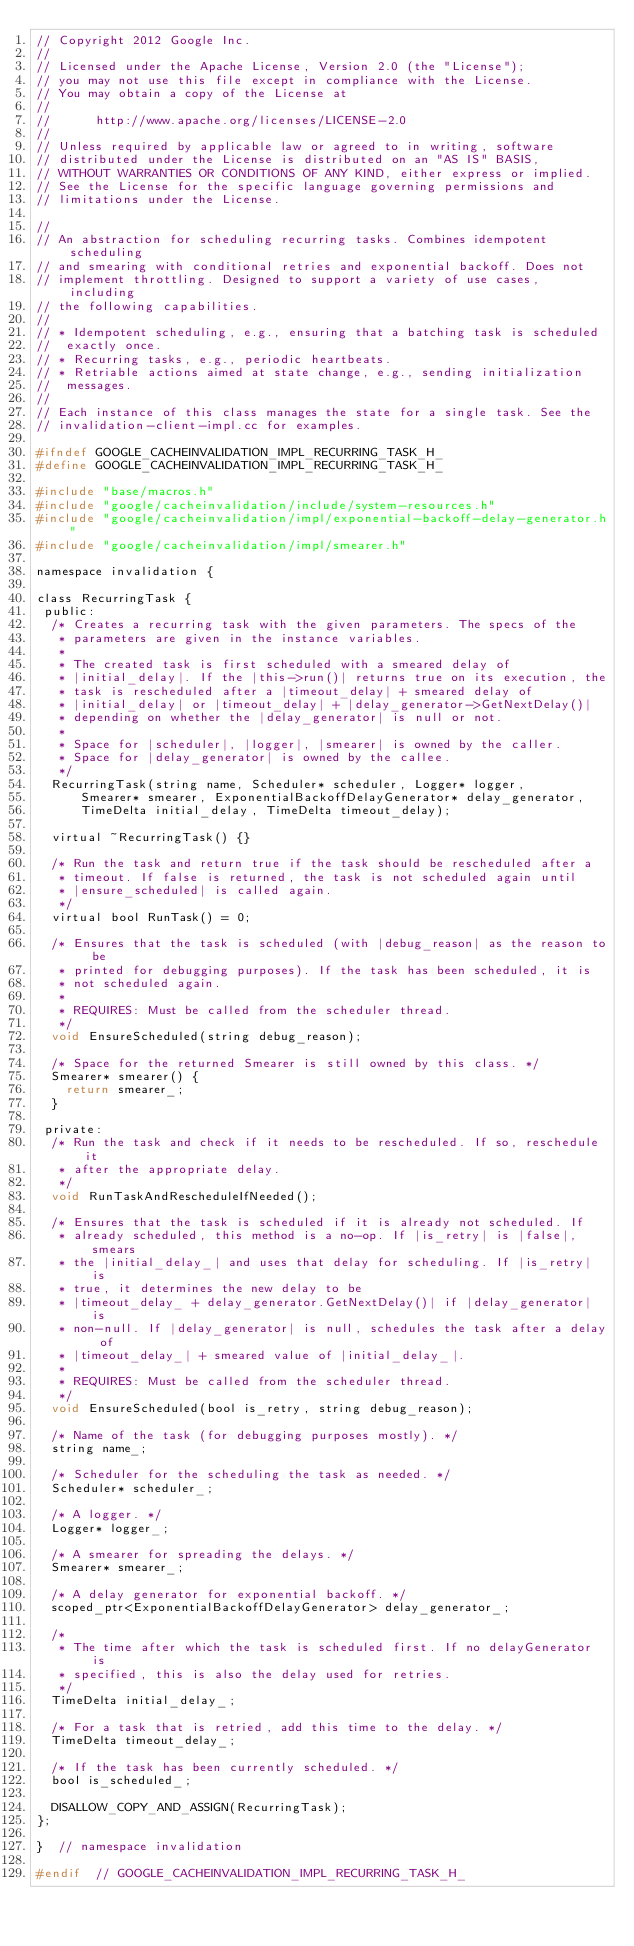<code> <loc_0><loc_0><loc_500><loc_500><_C_>// Copyright 2012 Google Inc.
//
// Licensed under the Apache License, Version 2.0 (the "License");
// you may not use this file except in compliance with the License.
// You may obtain a copy of the License at
//
//      http://www.apache.org/licenses/LICENSE-2.0
//
// Unless required by applicable law or agreed to in writing, software
// distributed under the License is distributed on an "AS IS" BASIS,
// WITHOUT WARRANTIES OR CONDITIONS OF ANY KIND, either express or implied.
// See the License for the specific language governing permissions and
// limitations under the License.

//
// An abstraction for scheduling recurring tasks. Combines idempotent scheduling
// and smearing with conditional retries and exponential backoff. Does not
// implement throttling. Designed to support a variety of use cases, including
// the following capabilities.
//
// * Idempotent scheduling, e.g., ensuring that a batching task is scheduled
//  exactly once.
// * Recurring tasks, e.g., periodic heartbeats.
// * Retriable actions aimed at state change, e.g., sending initialization
//  messages.
//
// Each instance of this class manages the state for a single task. See the
// invalidation-client-impl.cc for examples.

#ifndef GOOGLE_CACHEINVALIDATION_IMPL_RECURRING_TASK_H_
#define GOOGLE_CACHEINVALIDATION_IMPL_RECURRING_TASK_H_

#include "base/macros.h"
#include "google/cacheinvalidation/include/system-resources.h"
#include "google/cacheinvalidation/impl/exponential-backoff-delay-generator.h"
#include "google/cacheinvalidation/impl/smearer.h"

namespace invalidation {

class RecurringTask {
 public:
  /* Creates a recurring task with the given parameters. The specs of the
   * parameters are given in the instance variables.
   *
   * The created task is first scheduled with a smeared delay of
   * |initial_delay|. If the |this->run()| returns true on its execution, the
   * task is rescheduled after a |timeout_delay| + smeared delay of
   * |initial_delay| or |timeout_delay| + |delay_generator->GetNextDelay()|
   * depending on whether the |delay_generator| is null or not.
   *
   * Space for |scheduler|, |logger|, |smearer| is owned by the caller.
   * Space for |delay_generator| is owned by the callee.
   */
  RecurringTask(string name, Scheduler* scheduler, Logger* logger,
      Smearer* smearer, ExponentialBackoffDelayGenerator* delay_generator,
      TimeDelta initial_delay, TimeDelta timeout_delay);

  virtual ~RecurringTask() {}

  /* Run the task and return true if the task should be rescheduled after a
   * timeout. If false is returned, the task is not scheduled again until
   * |ensure_scheduled| is called again.
   */
  virtual bool RunTask() = 0;

  /* Ensures that the task is scheduled (with |debug_reason| as the reason to be
   * printed for debugging purposes). If the task has been scheduled, it is
   * not scheduled again.
   *
   * REQUIRES: Must be called from the scheduler thread.
   */
  void EnsureScheduled(string debug_reason);

  /* Space for the returned Smearer is still owned by this class. */
  Smearer* smearer() {
    return smearer_;
  }

 private:
  /* Run the task and check if it needs to be rescheduled. If so, reschedule it
   * after the appropriate delay.
   */
  void RunTaskAndRescheduleIfNeeded();

  /* Ensures that the task is scheduled if it is already not scheduled. If
   * already scheduled, this method is a no-op. If |is_retry| is |false|, smears
   * the |initial_delay_| and uses that delay for scheduling. If |is_retry| is
   * true, it determines the new delay to be
   * |timeout_delay_ + delay_generator.GetNextDelay()| if |delay_generator| is
   * non-null. If |delay_generator| is null, schedules the task after a delay of
   * |timeout_delay_| + smeared value of |initial_delay_|.
   *
   * REQUIRES: Must be called from the scheduler thread.
   */
  void EnsureScheduled(bool is_retry, string debug_reason);

  /* Name of the task (for debugging purposes mostly). */
  string name_;

  /* Scheduler for the scheduling the task as needed. */
  Scheduler* scheduler_;

  /* A logger. */
  Logger* logger_;

  /* A smearer for spreading the delays. */
  Smearer* smearer_;

  /* A delay generator for exponential backoff. */
  scoped_ptr<ExponentialBackoffDelayGenerator> delay_generator_;

  /*
   * The time after which the task is scheduled first. If no delayGenerator is
   * specified, this is also the delay used for retries.
   */
  TimeDelta initial_delay_;

  /* For a task that is retried, add this time to the delay. */
  TimeDelta timeout_delay_;

  /* If the task has been currently scheduled. */
  bool is_scheduled_;

  DISALLOW_COPY_AND_ASSIGN(RecurringTask);
};

}  // namespace invalidation

#endif  // GOOGLE_CACHEINVALIDATION_IMPL_RECURRING_TASK_H_
</code> 